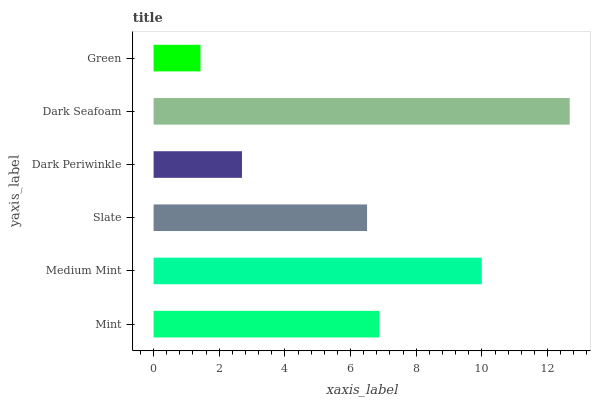Is Green the minimum?
Answer yes or no. Yes. Is Dark Seafoam the maximum?
Answer yes or no. Yes. Is Medium Mint the minimum?
Answer yes or no. No. Is Medium Mint the maximum?
Answer yes or no. No. Is Medium Mint greater than Mint?
Answer yes or no. Yes. Is Mint less than Medium Mint?
Answer yes or no. Yes. Is Mint greater than Medium Mint?
Answer yes or no. No. Is Medium Mint less than Mint?
Answer yes or no. No. Is Mint the high median?
Answer yes or no. Yes. Is Slate the low median?
Answer yes or no. Yes. Is Green the high median?
Answer yes or no. No. Is Mint the low median?
Answer yes or no. No. 